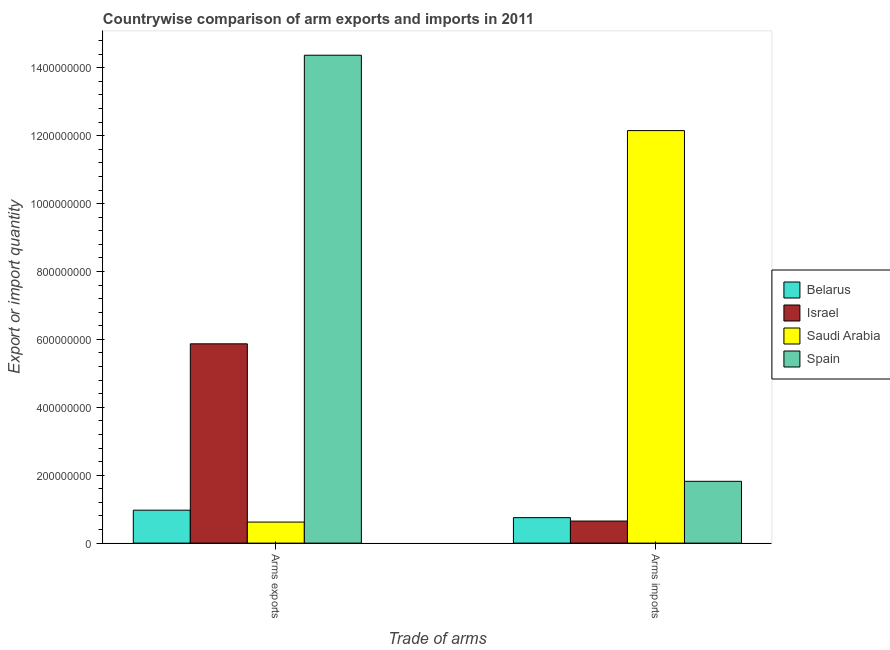How many groups of bars are there?
Offer a very short reply. 2. Are the number of bars on each tick of the X-axis equal?
Make the answer very short. Yes. How many bars are there on the 2nd tick from the left?
Give a very brief answer. 4. How many bars are there on the 1st tick from the right?
Keep it short and to the point. 4. What is the label of the 2nd group of bars from the left?
Provide a succinct answer. Arms imports. What is the arms exports in Belarus?
Ensure brevity in your answer.  9.70e+07. Across all countries, what is the maximum arms imports?
Offer a terse response. 1.22e+09. Across all countries, what is the minimum arms exports?
Your response must be concise. 6.20e+07. In which country was the arms imports maximum?
Keep it short and to the point. Saudi Arabia. What is the total arms imports in the graph?
Offer a very short reply. 1.54e+09. What is the difference between the arms imports in Israel and that in Spain?
Provide a short and direct response. -1.17e+08. What is the difference between the arms imports in Israel and the arms exports in Belarus?
Offer a terse response. -3.20e+07. What is the average arms exports per country?
Your answer should be compact. 5.46e+08. What is the difference between the arms imports and arms exports in Spain?
Provide a succinct answer. -1.26e+09. In how many countries, is the arms imports greater than 160000000 ?
Provide a succinct answer. 2. What is the ratio of the arms exports in Spain to that in Saudi Arabia?
Offer a very short reply. 23.18. Is the arms exports in Saudi Arabia less than that in Spain?
Provide a short and direct response. Yes. In how many countries, is the arms exports greater than the average arms exports taken over all countries?
Provide a short and direct response. 2. What does the 2nd bar from the left in Arms imports represents?
Your response must be concise. Israel. How many bars are there?
Offer a very short reply. 8. Are all the bars in the graph horizontal?
Keep it short and to the point. No. How many countries are there in the graph?
Give a very brief answer. 4. What is the difference between two consecutive major ticks on the Y-axis?
Provide a short and direct response. 2.00e+08. Are the values on the major ticks of Y-axis written in scientific E-notation?
Provide a short and direct response. No. Does the graph contain any zero values?
Keep it short and to the point. No. Where does the legend appear in the graph?
Give a very brief answer. Center right. What is the title of the graph?
Offer a very short reply. Countrywise comparison of arm exports and imports in 2011. Does "Korea (Democratic)" appear as one of the legend labels in the graph?
Your answer should be very brief. No. What is the label or title of the X-axis?
Offer a terse response. Trade of arms. What is the label or title of the Y-axis?
Provide a short and direct response. Export or import quantity. What is the Export or import quantity of Belarus in Arms exports?
Your response must be concise. 9.70e+07. What is the Export or import quantity in Israel in Arms exports?
Make the answer very short. 5.87e+08. What is the Export or import quantity of Saudi Arabia in Arms exports?
Ensure brevity in your answer.  6.20e+07. What is the Export or import quantity of Spain in Arms exports?
Make the answer very short. 1.44e+09. What is the Export or import quantity in Belarus in Arms imports?
Your answer should be very brief. 7.50e+07. What is the Export or import quantity of Israel in Arms imports?
Keep it short and to the point. 6.50e+07. What is the Export or import quantity in Saudi Arabia in Arms imports?
Keep it short and to the point. 1.22e+09. What is the Export or import quantity in Spain in Arms imports?
Your answer should be compact. 1.82e+08. Across all Trade of arms, what is the maximum Export or import quantity of Belarus?
Keep it short and to the point. 9.70e+07. Across all Trade of arms, what is the maximum Export or import quantity of Israel?
Your response must be concise. 5.87e+08. Across all Trade of arms, what is the maximum Export or import quantity of Saudi Arabia?
Provide a short and direct response. 1.22e+09. Across all Trade of arms, what is the maximum Export or import quantity of Spain?
Make the answer very short. 1.44e+09. Across all Trade of arms, what is the minimum Export or import quantity of Belarus?
Ensure brevity in your answer.  7.50e+07. Across all Trade of arms, what is the minimum Export or import quantity of Israel?
Your answer should be very brief. 6.50e+07. Across all Trade of arms, what is the minimum Export or import quantity of Saudi Arabia?
Your response must be concise. 6.20e+07. Across all Trade of arms, what is the minimum Export or import quantity of Spain?
Provide a succinct answer. 1.82e+08. What is the total Export or import quantity in Belarus in the graph?
Provide a short and direct response. 1.72e+08. What is the total Export or import quantity of Israel in the graph?
Keep it short and to the point. 6.52e+08. What is the total Export or import quantity in Saudi Arabia in the graph?
Ensure brevity in your answer.  1.28e+09. What is the total Export or import quantity of Spain in the graph?
Make the answer very short. 1.62e+09. What is the difference between the Export or import quantity in Belarus in Arms exports and that in Arms imports?
Keep it short and to the point. 2.20e+07. What is the difference between the Export or import quantity in Israel in Arms exports and that in Arms imports?
Your response must be concise. 5.22e+08. What is the difference between the Export or import quantity of Saudi Arabia in Arms exports and that in Arms imports?
Your response must be concise. -1.15e+09. What is the difference between the Export or import quantity of Spain in Arms exports and that in Arms imports?
Give a very brief answer. 1.26e+09. What is the difference between the Export or import quantity in Belarus in Arms exports and the Export or import quantity in Israel in Arms imports?
Your answer should be compact. 3.20e+07. What is the difference between the Export or import quantity of Belarus in Arms exports and the Export or import quantity of Saudi Arabia in Arms imports?
Provide a succinct answer. -1.12e+09. What is the difference between the Export or import quantity in Belarus in Arms exports and the Export or import quantity in Spain in Arms imports?
Make the answer very short. -8.50e+07. What is the difference between the Export or import quantity of Israel in Arms exports and the Export or import quantity of Saudi Arabia in Arms imports?
Offer a very short reply. -6.28e+08. What is the difference between the Export or import quantity of Israel in Arms exports and the Export or import quantity of Spain in Arms imports?
Provide a succinct answer. 4.05e+08. What is the difference between the Export or import quantity of Saudi Arabia in Arms exports and the Export or import quantity of Spain in Arms imports?
Provide a succinct answer. -1.20e+08. What is the average Export or import quantity in Belarus per Trade of arms?
Keep it short and to the point. 8.60e+07. What is the average Export or import quantity of Israel per Trade of arms?
Your answer should be very brief. 3.26e+08. What is the average Export or import quantity in Saudi Arabia per Trade of arms?
Your response must be concise. 6.38e+08. What is the average Export or import quantity in Spain per Trade of arms?
Provide a succinct answer. 8.10e+08. What is the difference between the Export or import quantity of Belarus and Export or import quantity of Israel in Arms exports?
Ensure brevity in your answer.  -4.90e+08. What is the difference between the Export or import quantity of Belarus and Export or import quantity of Saudi Arabia in Arms exports?
Provide a short and direct response. 3.50e+07. What is the difference between the Export or import quantity of Belarus and Export or import quantity of Spain in Arms exports?
Keep it short and to the point. -1.34e+09. What is the difference between the Export or import quantity of Israel and Export or import quantity of Saudi Arabia in Arms exports?
Your response must be concise. 5.25e+08. What is the difference between the Export or import quantity of Israel and Export or import quantity of Spain in Arms exports?
Offer a very short reply. -8.50e+08. What is the difference between the Export or import quantity in Saudi Arabia and Export or import quantity in Spain in Arms exports?
Provide a succinct answer. -1.38e+09. What is the difference between the Export or import quantity in Belarus and Export or import quantity in Israel in Arms imports?
Your answer should be compact. 1.00e+07. What is the difference between the Export or import quantity of Belarus and Export or import quantity of Saudi Arabia in Arms imports?
Offer a terse response. -1.14e+09. What is the difference between the Export or import quantity of Belarus and Export or import quantity of Spain in Arms imports?
Your answer should be very brief. -1.07e+08. What is the difference between the Export or import quantity in Israel and Export or import quantity in Saudi Arabia in Arms imports?
Give a very brief answer. -1.15e+09. What is the difference between the Export or import quantity in Israel and Export or import quantity in Spain in Arms imports?
Provide a succinct answer. -1.17e+08. What is the difference between the Export or import quantity in Saudi Arabia and Export or import quantity in Spain in Arms imports?
Make the answer very short. 1.03e+09. What is the ratio of the Export or import quantity of Belarus in Arms exports to that in Arms imports?
Keep it short and to the point. 1.29. What is the ratio of the Export or import quantity of Israel in Arms exports to that in Arms imports?
Keep it short and to the point. 9.03. What is the ratio of the Export or import quantity of Saudi Arabia in Arms exports to that in Arms imports?
Provide a short and direct response. 0.05. What is the ratio of the Export or import quantity of Spain in Arms exports to that in Arms imports?
Your answer should be very brief. 7.9. What is the difference between the highest and the second highest Export or import quantity in Belarus?
Provide a succinct answer. 2.20e+07. What is the difference between the highest and the second highest Export or import quantity in Israel?
Ensure brevity in your answer.  5.22e+08. What is the difference between the highest and the second highest Export or import quantity of Saudi Arabia?
Your response must be concise. 1.15e+09. What is the difference between the highest and the second highest Export or import quantity in Spain?
Ensure brevity in your answer.  1.26e+09. What is the difference between the highest and the lowest Export or import quantity in Belarus?
Keep it short and to the point. 2.20e+07. What is the difference between the highest and the lowest Export or import quantity of Israel?
Provide a short and direct response. 5.22e+08. What is the difference between the highest and the lowest Export or import quantity in Saudi Arabia?
Give a very brief answer. 1.15e+09. What is the difference between the highest and the lowest Export or import quantity in Spain?
Your answer should be very brief. 1.26e+09. 